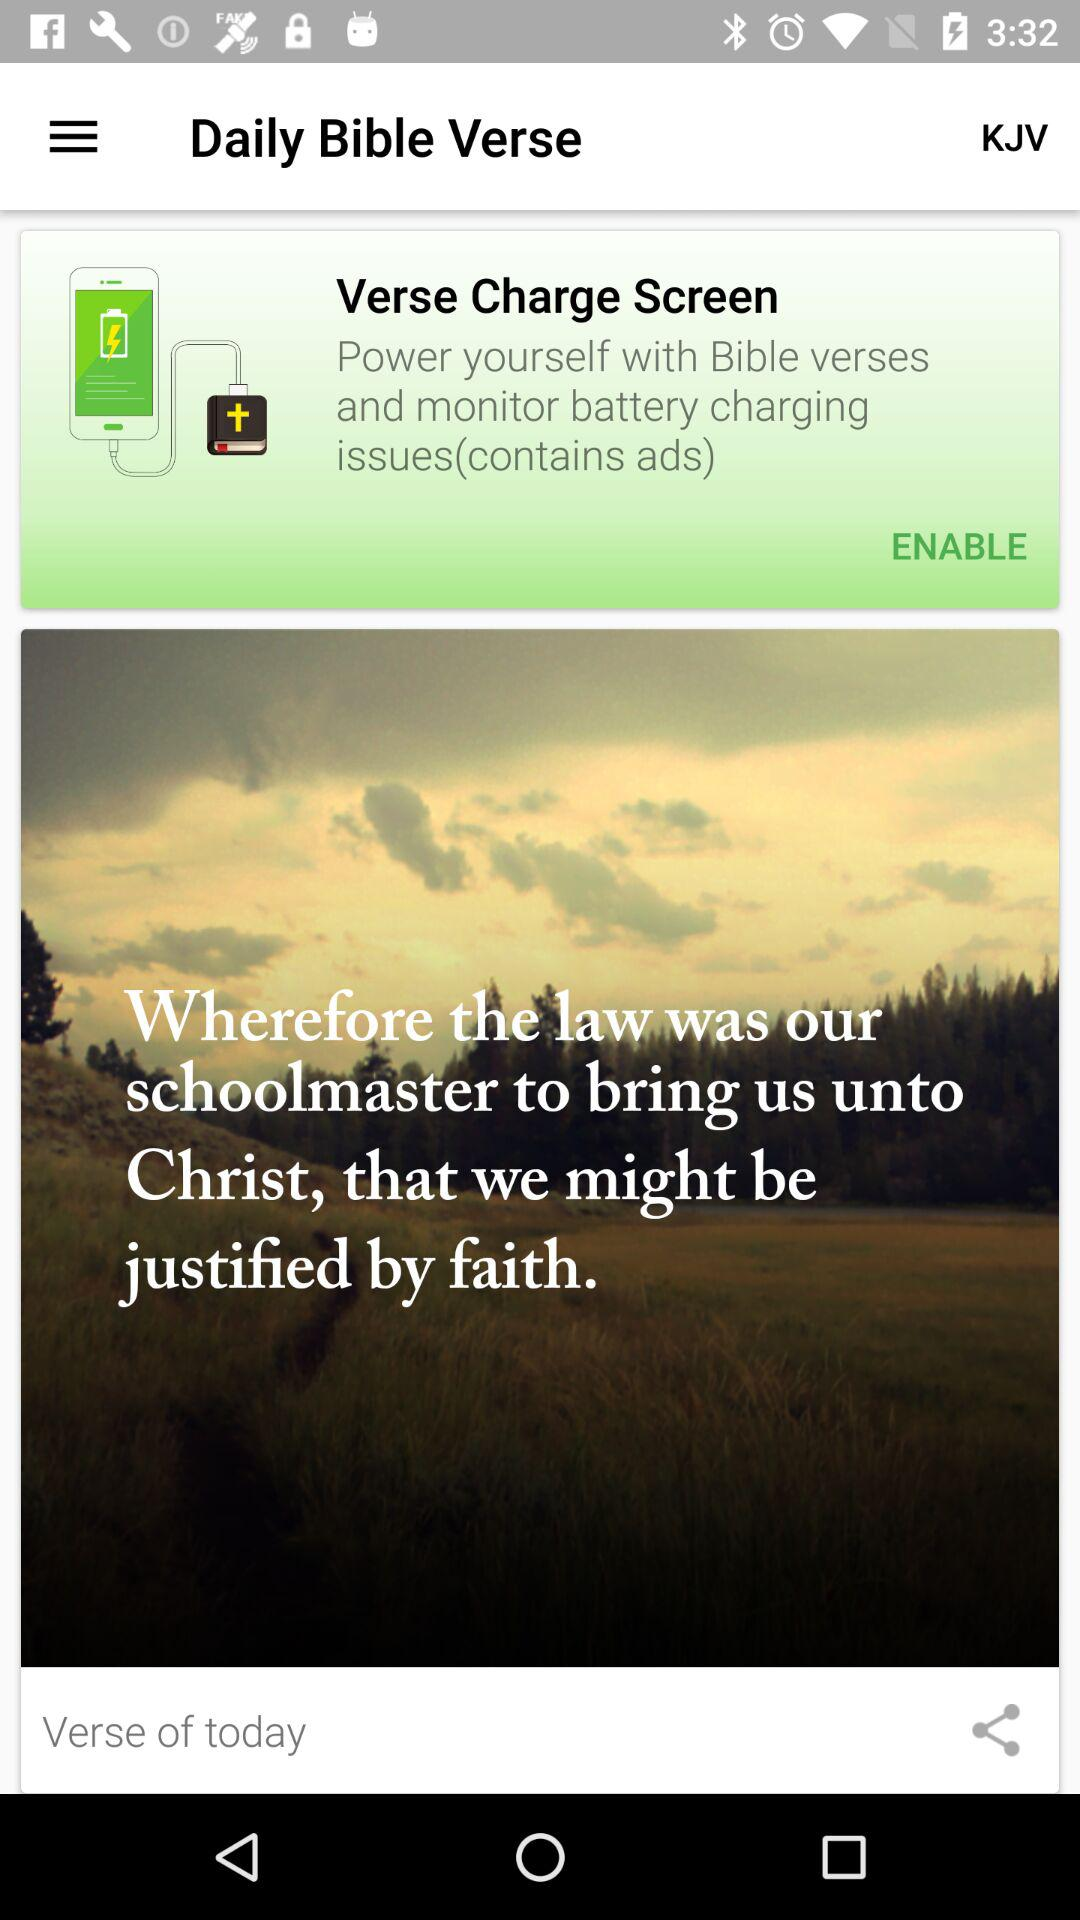What is the app name? The app name is "Daily Bible Verse". 